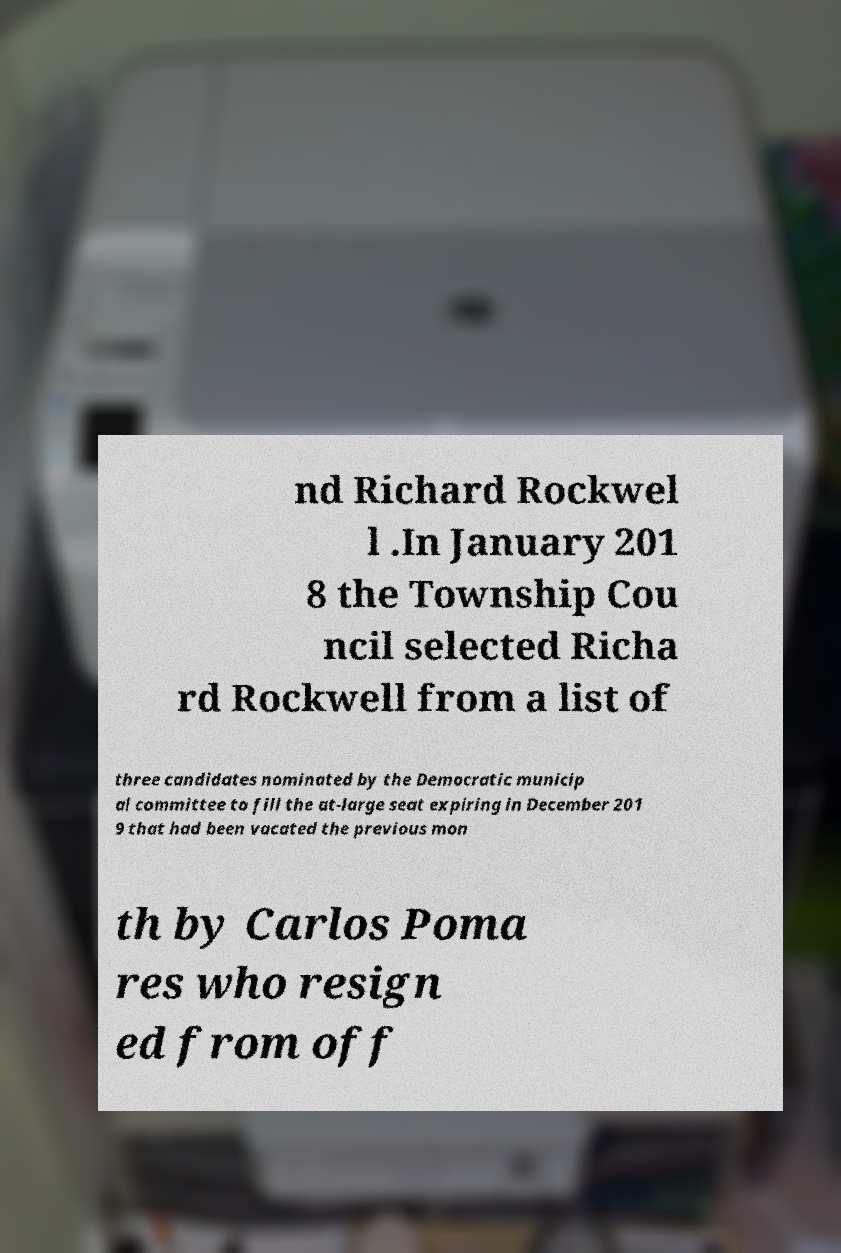Please read and relay the text visible in this image. What does it say? nd Richard Rockwel l .In January 201 8 the Township Cou ncil selected Richa rd Rockwell from a list of three candidates nominated by the Democratic municip al committee to fill the at-large seat expiring in December 201 9 that had been vacated the previous mon th by Carlos Poma res who resign ed from off 